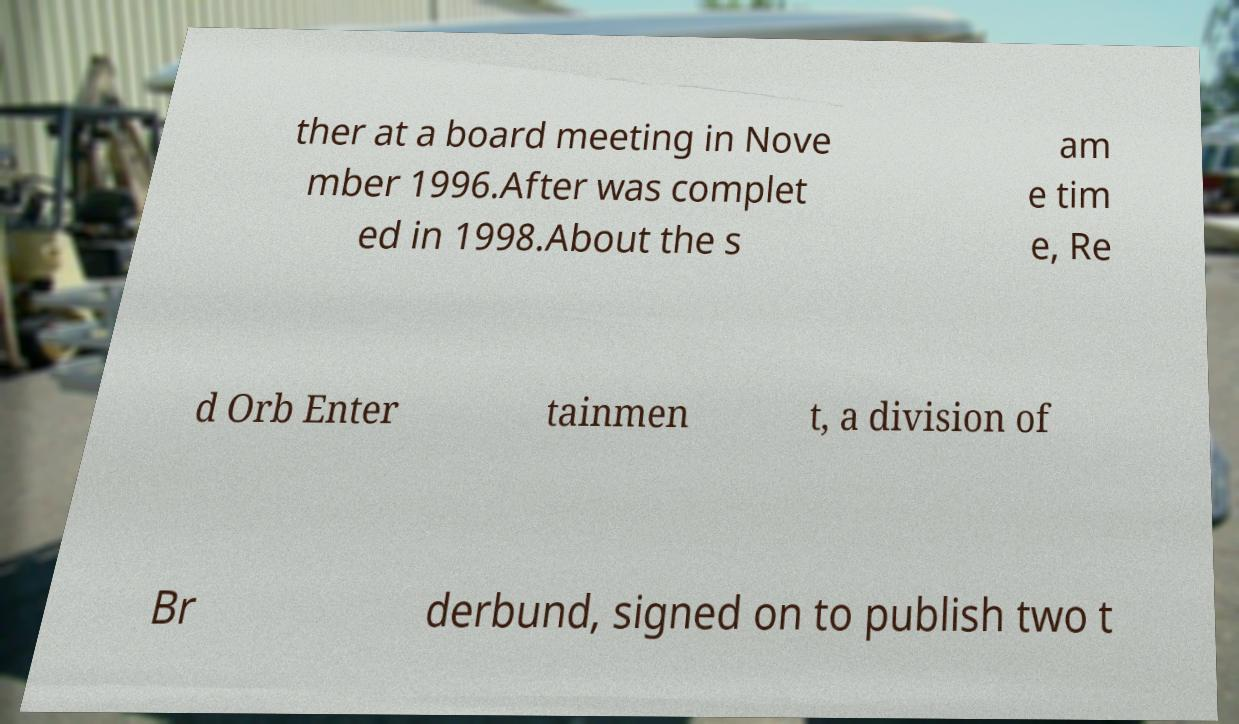Can you accurately transcribe the text from the provided image for me? ther at a board meeting in Nove mber 1996.After was complet ed in 1998.About the s am e tim e, Re d Orb Enter tainmen t, a division of Br derbund, signed on to publish two t 